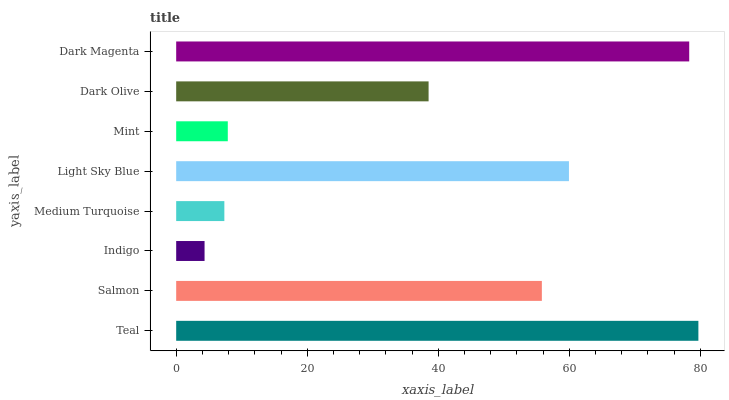Is Indigo the minimum?
Answer yes or no. Yes. Is Teal the maximum?
Answer yes or no. Yes. Is Salmon the minimum?
Answer yes or no. No. Is Salmon the maximum?
Answer yes or no. No. Is Teal greater than Salmon?
Answer yes or no. Yes. Is Salmon less than Teal?
Answer yes or no. Yes. Is Salmon greater than Teal?
Answer yes or no. No. Is Teal less than Salmon?
Answer yes or no. No. Is Salmon the high median?
Answer yes or no. Yes. Is Dark Olive the low median?
Answer yes or no. Yes. Is Medium Turquoise the high median?
Answer yes or no. No. Is Teal the low median?
Answer yes or no. No. 